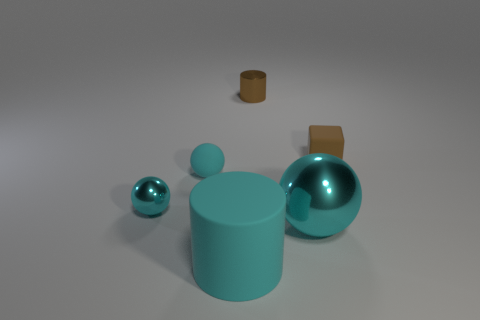Do the matte cylinder and the matte cube have the same size?
Make the answer very short. No. Are there any gray things made of the same material as the large sphere?
Ensure brevity in your answer.  No. There is a shiny cylinder that is the same color as the cube; what is its size?
Ensure brevity in your answer.  Small. What number of spheres are brown objects or big metallic objects?
Make the answer very short. 1. How big is the matte sphere?
Give a very brief answer. Small. What number of matte balls are on the right side of the brown metallic thing?
Offer a terse response. 0. There is a shiny sphere that is in front of the cyan metal sphere that is behind the large metal object; what size is it?
Provide a succinct answer. Large. Do the big thing right of the large matte cylinder and the small cyan rubber thing on the left side of the large matte cylinder have the same shape?
Ensure brevity in your answer.  Yes. There is a brown shiny thing that is behind the tiny shiny ball in front of the metallic cylinder; what shape is it?
Provide a succinct answer. Cylinder. How big is the thing that is on the left side of the big cyan metal ball and behind the rubber sphere?
Your answer should be compact. Small. 